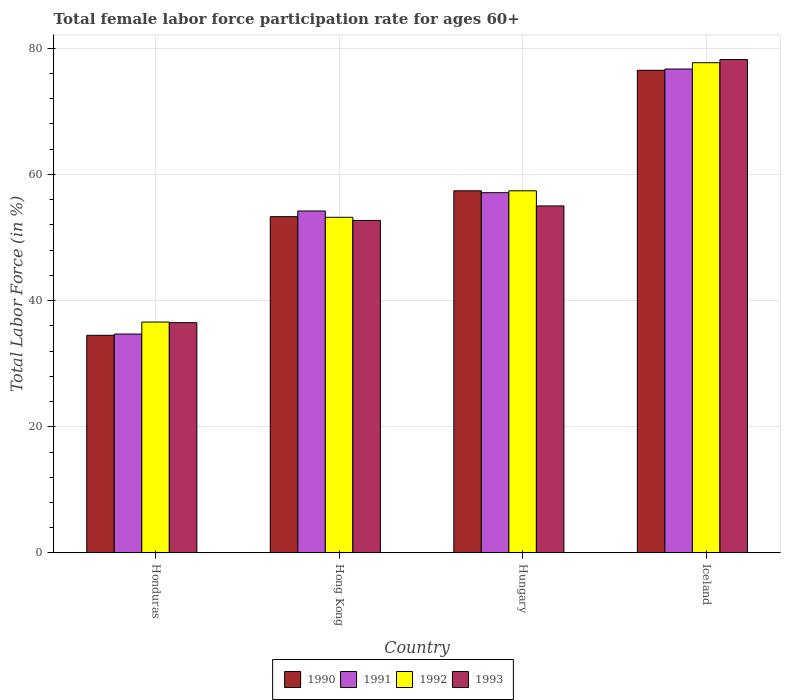How many groups of bars are there?
Your answer should be compact. 4. Are the number of bars per tick equal to the number of legend labels?
Give a very brief answer. Yes. How many bars are there on the 3rd tick from the right?
Give a very brief answer. 4. What is the label of the 2nd group of bars from the left?
Offer a terse response. Hong Kong. What is the female labor force participation rate in 1992 in Honduras?
Offer a terse response. 36.6. Across all countries, what is the maximum female labor force participation rate in 1993?
Your response must be concise. 78.2. Across all countries, what is the minimum female labor force participation rate in 1991?
Give a very brief answer. 34.7. In which country was the female labor force participation rate in 1990 minimum?
Your answer should be very brief. Honduras. What is the total female labor force participation rate in 1993 in the graph?
Your answer should be very brief. 222.4. What is the difference between the female labor force participation rate in 1993 in Honduras and that in Iceland?
Ensure brevity in your answer.  -41.7. What is the difference between the female labor force participation rate in 1992 in Honduras and the female labor force participation rate in 1991 in Hong Kong?
Your response must be concise. -17.6. What is the average female labor force participation rate in 1991 per country?
Provide a short and direct response. 55.67. What is the difference between the female labor force participation rate of/in 1993 and female labor force participation rate of/in 1992 in Hong Kong?
Offer a terse response. -0.5. What is the ratio of the female labor force participation rate in 1992 in Honduras to that in Hungary?
Keep it short and to the point. 0.64. Is the female labor force participation rate in 1991 in Honduras less than that in Hungary?
Provide a succinct answer. Yes. What is the difference between the highest and the second highest female labor force participation rate in 1993?
Your answer should be very brief. -25.5. What is the difference between the highest and the lowest female labor force participation rate in 1993?
Ensure brevity in your answer.  41.7. Is the sum of the female labor force participation rate in 1993 in Honduras and Hungary greater than the maximum female labor force participation rate in 1991 across all countries?
Provide a succinct answer. Yes. What does the 4th bar from the right in Hong Kong represents?
Ensure brevity in your answer.  1990. Is it the case that in every country, the sum of the female labor force participation rate in 1991 and female labor force participation rate in 1993 is greater than the female labor force participation rate in 1992?
Provide a succinct answer. Yes. How many bars are there?
Your answer should be very brief. 16. Are all the bars in the graph horizontal?
Make the answer very short. No. What is the difference between two consecutive major ticks on the Y-axis?
Keep it short and to the point. 20. Does the graph contain any zero values?
Your answer should be compact. No. What is the title of the graph?
Ensure brevity in your answer.  Total female labor force participation rate for ages 60+. Does "2000" appear as one of the legend labels in the graph?
Your answer should be very brief. No. What is the label or title of the X-axis?
Offer a very short reply. Country. What is the label or title of the Y-axis?
Provide a succinct answer. Total Labor Force (in %). What is the Total Labor Force (in %) in 1990 in Honduras?
Your answer should be very brief. 34.5. What is the Total Labor Force (in %) of 1991 in Honduras?
Offer a very short reply. 34.7. What is the Total Labor Force (in %) of 1992 in Honduras?
Keep it short and to the point. 36.6. What is the Total Labor Force (in %) in 1993 in Honduras?
Provide a short and direct response. 36.5. What is the Total Labor Force (in %) of 1990 in Hong Kong?
Provide a short and direct response. 53.3. What is the Total Labor Force (in %) of 1991 in Hong Kong?
Offer a terse response. 54.2. What is the Total Labor Force (in %) of 1992 in Hong Kong?
Offer a terse response. 53.2. What is the Total Labor Force (in %) of 1993 in Hong Kong?
Ensure brevity in your answer.  52.7. What is the Total Labor Force (in %) of 1990 in Hungary?
Ensure brevity in your answer.  57.4. What is the Total Labor Force (in %) of 1991 in Hungary?
Keep it short and to the point. 57.1. What is the Total Labor Force (in %) in 1992 in Hungary?
Your answer should be compact. 57.4. What is the Total Labor Force (in %) in 1993 in Hungary?
Your response must be concise. 55. What is the Total Labor Force (in %) of 1990 in Iceland?
Offer a terse response. 76.5. What is the Total Labor Force (in %) of 1991 in Iceland?
Offer a terse response. 76.7. What is the Total Labor Force (in %) of 1992 in Iceland?
Offer a terse response. 77.7. What is the Total Labor Force (in %) in 1993 in Iceland?
Your answer should be very brief. 78.2. Across all countries, what is the maximum Total Labor Force (in %) of 1990?
Provide a short and direct response. 76.5. Across all countries, what is the maximum Total Labor Force (in %) of 1991?
Give a very brief answer. 76.7. Across all countries, what is the maximum Total Labor Force (in %) of 1992?
Your response must be concise. 77.7. Across all countries, what is the maximum Total Labor Force (in %) of 1993?
Your answer should be compact. 78.2. Across all countries, what is the minimum Total Labor Force (in %) of 1990?
Your answer should be very brief. 34.5. Across all countries, what is the minimum Total Labor Force (in %) in 1991?
Provide a succinct answer. 34.7. Across all countries, what is the minimum Total Labor Force (in %) in 1992?
Provide a short and direct response. 36.6. Across all countries, what is the minimum Total Labor Force (in %) in 1993?
Your response must be concise. 36.5. What is the total Total Labor Force (in %) of 1990 in the graph?
Keep it short and to the point. 221.7. What is the total Total Labor Force (in %) in 1991 in the graph?
Your answer should be very brief. 222.7. What is the total Total Labor Force (in %) of 1992 in the graph?
Offer a very short reply. 224.9. What is the total Total Labor Force (in %) of 1993 in the graph?
Offer a very short reply. 222.4. What is the difference between the Total Labor Force (in %) in 1990 in Honduras and that in Hong Kong?
Give a very brief answer. -18.8. What is the difference between the Total Labor Force (in %) in 1991 in Honduras and that in Hong Kong?
Provide a succinct answer. -19.5. What is the difference between the Total Labor Force (in %) of 1992 in Honduras and that in Hong Kong?
Provide a short and direct response. -16.6. What is the difference between the Total Labor Force (in %) of 1993 in Honduras and that in Hong Kong?
Offer a terse response. -16.2. What is the difference between the Total Labor Force (in %) in 1990 in Honduras and that in Hungary?
Provide a succinct answer. -22.9. What is the difference between the Total Labor Force (in %) in 1991 in Honduras and that in Hungary?
Your answer should be compact. -22.4. What is the difference between the Total Labor Force (in %) of 1992 in Honduras and that in Hungary?
Make the answer very short. -20.8. What is the difference between the Total Labor Force (in %) in 1993 in Honduras and that in Hungary?
Your response must be concise. -18.5. What is the difference between the Total Labor Force (in %) of 1990 in Honduras and that in Iceland?
Your response must be concise. -42. What is the difference between the Total Labor Force (in %) in 1991 in Honduras and that in Iceland?
Keep it short and to the point. -42. What is the difference between the Total Labor Force (in %) of 1992 in Honduras and that in Iceland?
Offer a terse response. -41.1. What is the difference between the Total Labor Force (in %) of 1993 in Honduras and that in Iceland?
Provide a short and direct response. -41.7. What is the difference between the Total Labor Force (in %) in 1991 in Hong Kong and that in Hungary?
Make the answer very short. -2.9. What is the difference between the Total Labor Force (in %) of 1992 in Hong Kong and that in Hungary?
Your response must be concise. -4.2. What is the difference between the Total Labor Force (in %) in 1993 in Hong Kong and that in Hungary?
Ensure brevity in your answer.  -2.3. What is the difference between the Total Labor Force (in %) in 1990 in Hong Kong and that in Iceland?
Give a very brief answer. -23.2. What is the difference between the Total Labor Force (in %) of 1991 in Hong Kong and that in Iceland?
Provide a succinct answer. -22.5. What is the difference between the Total Labor Force (in %) of 1992 in Hong Kong and that in Iceland?
Give a very brief answer. -24.5. What is the difference between the Total Labor Force (in %) in 1993 in Hong Kong and that in Iceland?
Give a very brief answer. -25.5. What is the difference between the Total Labor Force (in %) of 1990 in Hungary and that in Iceland?
Keep it short and to the point. -19.1. What is the difference between the Total Labor Force (in %) in 1991 in Hungary and that in Iceland?
Your answer should be very brief. -19.6. What is the difference between the Total Labor Force (in %) of 1992 in Hungary and that in Iceland?
Make the answer very short. -20.3. What is the difference between the Total Labor Force (in %) in 1993 in Hungary and that in Iceland?
Ensure brevity in your answer.  -23.2. What is the difference between the Total Labor Force (in %) of 1990 in Honduras and the Total Labor Force (in %) of 1991 in Hong Kong?
Keep it short and to the point. -19.7. What is the difference between the Total Labor Force (in %) in 1990 in Honduras and the Total Labor Force (in %) in 1992 in Hong Kong?
Keep it short and to the point. -18.7. What is the difference between the Total Labor Force (in %) in 1990 in Honduras and the Total Labor Force (in %) in 1993 in Hong Kong?
Your answer should be compact. -18.2. What is the difference between the Total Labor Force (in %) of 1991 in Honduras and the Total Labor Force (in %) of 1992 in Hong Kong?
Provide a short and direct response. -18.5. What is the difference between the Total Labor Force (in %) of 1992 in Honduras and the Total Labor Force (in %) of 1993 in Hong Kong?
Ensure brevity in your answer.  -16.1. What is the difference between the Total Labor Force (in %) of 1990 in Honduras and the Total Labor Force (in %) of 1991 in Hungary?
Keep it short and to the point. -22.6. What is the difference between the Total Labor Force (in %) of 1990 in Honduras and the Total Labor Force (in %) of 1992 in Hungary?
Your answer should be very brief. -22.9. What is the difference between the Total Labor Force (in %) in 1990 in Honduras and the Total Labor Force (in %) in 1993 in Hungary?
Ensure brevity in your answer.  -20.5. What is the difference between the Total Labor Force (in %) in 1991 in Honduras and the Total Labor Force (in %) in 1992 in Hungary?
Provide a succinct answer. -22.7. What is the difference between the Total Labor Force (in %) in 1991 in Honduras and the Total Labor Force (in %) in 1993 in Hungary?
Keep it short and to the point. -20.3. What is the difference between the Total Labor Force (in %) of 1992 in Honduras and the Total Labor Force (in %) of 1993 in Hungary?
Provide a succinct answer. -18.4. What is the difference between the Total Labor Force (in %) in 1990 in Honduras and the Total Labor Force (in %) in 1991 in Iceland?
Offer a very short reply. -42.2. What is the difference between the Total Labor Force (in %) in 1990 in Honduras and the Total Labor Force (in %) in 1992 in Iceland?
Offer a terse response. -43.2. What is the difference between the Total Labor Force (in %) of 1990 in Honduras and the Total Labor Force (in %) of 1993 in Iceland?
Keep it short and to the point. -43.7. What is the difference between the Total Labor Force (in %) of 1991 in Honduras and the Total Labor Force (in %) of 1992 in Iceland?
Make the answer very short. -43. What is the difference between the Total Labor Force (in %) of 1991 in Honduras and the Total Labor Force (in %) of 1993 in Iceland?
Offer a terse response. -43.5. What is the difference between the Total Labor Force (in %) in 1992 in Honduras and the Total Labor Force (in %) in 1993 in Iceland?
Provide a short and direct response. -41.6. What is the difference between the Total Labor Force (in %) in 1990 in Hong Kong and the Total Labor Force (in %) in 1992 in Hungary?
Ensure brevity in your answer.  -4.1. What is the difference between the Total Labor Force (in %) of 1992 in Hong Kong and the Total Labor Force (in %) of 1993 in Hungary?
Keep it short and to the point. -1.8. What is the difference between the Total Labor Force (in %) of 1990 in Hong Kong and the Total Labor Force (in %) of 1991 in Iceland?
Give a very brief answer. -23.4. What is the difference between the Total Labor Force (in %) of 1990 in Hong Kong and the Total Labor Force (in %) of 1992 in Iceland?
Keep it short and to the point. -24.4. What is the difference between the Total Labor Force (in %) in 1990 in Hong Kong and the Total Labor Force (in %) in 1993 in Iceland?
Your response must be concise. -24.9. What is the difference between the Total Labor Force (in %) in 1991 in Hong Kong and the Total Labor Force (in %) in 1992 in Iceland?
Offer a terse response. -23.5. What is the difference between the Total Labor Force (in %) of 1992 in Hong Kong and the Total Labor Force (in %) of 1993 in Iceland?
Offer a very short reply. -25. What is the difference between the Total Labor Force (in %) in 1990 in Hungary and the Total Labor Force (in %) in 1991 in Iceland?
Provide a short and direct response. -19.3. What is the difference between the Total Labor Force (in %) in 1990 in Hungary and the Total Labor Force (in %) in 1992 in Iceland?
Your answer should be compact. -20.3. What is the difference between the Total Labor Force (in %) in 1990 in Hungary and the Total Labor Force (in %) in 1993 in Iceland?
Offer a very short reply. -20.8. What is the difference between the Total Labor Force (in %) in 1991 in Hungary and the Total Labor Force (in %) in 1992 in Iceland?
Your answer should be compact. -20.6. What is the difference between the Total Labor Force (in %) of 1991 in Hungary and the Total Labor Force (in %) of 1993 in Iceland?
Provide a succinct answer. -21.1. What is the difference between the Total Labor Force (in %) of 1992 in Hungary and the Total Labor Force (in %) of 1993 in Iceland?
Your answer should be compact. -20.8. What is the average Total Labor Force (in %) of 1990 per country?
Ensure brevity in your answer.  55.42. What is the average Total Labor Force (in %) of 1991 per country?
Provide a short and direct response. 55.67. What is the average Total Labor Force (in %) of 1992 per country?
Offer a terse response. 56.23. What is the average Total Labor Force (in %) in 1993 per country?
Your response must be concise. 55.6. What is the difference between the Total Labor Force (in %) of 1990 and Total Labor Force (in %) of 1991 in Honduras?
Offer a terse response. -0.2. What is the difference between the Total Labor Force (in %) of 1990 and Total Labor Force (in %) of 1992 in Honduras?
Make the answer very short. -2.1. What is the difference between the Total Labor Force (in %) of 1991 and Total Labor Force (in %) of 1992 in Honduras?
Your answer should be compact. -1.9. What is the difference between the Total Labor Force (in %) of 1991 and Total Labor Force (in %) of 1993 in Honduras?
Your answer should be very brief. -1.8. What is the difference between the Total Labor Force (in %) of 1992 and Total Labor Force (in %) of 1993 in Honduras?
Provide a succinct answer. 0.1. What is the difference between the Total Labor Force (in %) of 1991 and Total Labor Force (in %) of 1993 in Hong Kong?
Keep it short and to the point. 1.5. What is the difference between the Total Labor Force (in %) of 1992 and Total Labor Force (in %) of 1993 in Hong Kong?
Provide a short and direct response. 0.5. What is the difference between the Total Labor Force (in %) in 1990 and Total Labor Force (in %) in 1993 in Hungary?
Your response must be concise. 2.4. What is the difference between the Total Labor Force (in %) of 1991 and Total Labor Force (in %) of 1992 in Hungary?
Provide a short and direct response. -0.3. What is the difference between the Total Labor Force (in %) of 1992 and Total Labor Force (in %) of 1993 in Hungary?
Give a very brief answer. 2.4. What is the difference between the Total Labor Force (in %) in 1990 and Total Labor Force (in %) in 1991 in Iceland?
Your response must be concise. -0.2. What is the ratio of the Total Labor Force (in %) of 1990 in Honduras to that in Hong Kong?
Keep it short and to the point. 0.65. What is the ratio of the Total Labor Force (in %) of 1991 in Honduras to that in Hong Kong?
Provide a succinct answer. 0.64. What is the ratio of the Total Labor Force (in %) of 1992 in Honduras to that in Hong Kong?
Offer a very short reply. 0.69. What is the ratio of the Total Labor Force (in %) of 1993 in Honduras to that in Hong Kong?
Give a very brief answer. 0.69. What is the ratio of the Total Labor Force (in %) of 1990 in Honduras to that in Hungary?
Make the answer very short. 0.6. What is the ratio of the Total Labor Force (in %) of 1991 in Honduras to that in Hungary?
Provide a succinct answer. 0.61. What is the ratio of the Total Labor Force (in %) of 1992 in Honduras to that in Hungary?
Keep it short and to the point. 0.64. What is the ratio of the Total Labor Force (in %) of 1993 in Honduras to that in Hungary?
Make the answer very short. 0.66. What is the ratio of the Total Labor Force (in %) of 1990 in Honduras to that in Iceland?
Your response must be concise. 0.45. What is the ratio of the Total Labor Force (in %) in 1991 in Honduras to that in Iceland?
Keep it short and to the point. 0.45. What is the ratio of the Total Labor Force (in %) in 1992 in Honduras to that in Iceland?
Make the answer very short. 0.47. What is the ratio of the Total Labor Force (in %) of 1993 in Honduras to that in Iceland?
Your response must be concise. 0.47. What is the ratio of the Total Labor Force (in %) of 1990 in Hong Kong to that in Hungary?
Ensure brevity in your answer.  0.93. What is the ratio of the Total Labor Force (in %) of 1991 in Hong Kong to that in Hungary?
Give a very brief answer. 0.95. What is the ratio of the Total Labor Force (in %) of 1992 in Hong Kong to that in Hungary?
Your answer should be very brief. 0.93. What is the ratio of the Total Labor Force (in %) in 1993 in Hong Kong to that in Hungary?
Ensure brevity in your answer.  0.96. What is the ratio of the Total Labor Force (in %) of 1990 in Hong Kong to that in Iceland?
Provide a succinct answer. 0.7. What is the ratio of the Total Labor Force (in %) in 1991 in Hong Kong to that in Iceland?
Ensure brevity in your answer.  0.71. What is the ratio of the Total Labor Force (in %) of 1992 in Hong Kong to that in Iceland?
Offer a very short reply. 0.68. What is the ratio of the Total Labor Force (in %) of 1993 in Hong Kong to that in Iceland?
Your answer should be compact. 0.67. What is the ratio of the Total Labor Force (in %) of 1990 in Hungary to that in Iceland?
Your answer should be compact. 0.75. What is the ratio of the Total Labor Force (in %) of 1991 in Hungary to that in Iceland?
Provide a short and direct response. 0.74. What is the ratio of the Total Labor Force (in %) of 1992 in Hungary to that in Iceland?
Give a very brief answer. 0.74. What is the ratio of the Total Labor Force (in %) of 1993 in Hungary to that in Iceland?
Your answer should be very brief. 0.7. What is the difference between the highest and the second highest Total Labor Force (in %) in 1990?
Your response must be concise. 19.1. What is the difference between the highest and the second highest Total Labor Force (in %) in 1991?
Your answer should be very brief. 19.6. What is the difference between the highest and the second highest Total Labor Force (in %) in 1992?
Make the answer very short. 20.3. What is the difference between the highest and the second highest Total Labor Force (in %) in 1993?
Your response must be concise. 23.2. What is the difference between the highest and the lowest Total Labor Force (in %) in 1990?
Keep it short and to the point. 42. What is the difference between the highest and the lowest Total Labor Force (in %) of 1991?
Your answer should be compact. 42. What is the difference between the highest and the lowest Total Labor Force (in %) in 1992?
Give a very brief answer. 41.1. What is the difference between the highest and the lowest Total Labor Force (in %) of 1993?
Offer a very short reply. 41.7. 